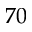<formula> <loc_0><loc_0><loc_500><loc_500>7 0</formula> 